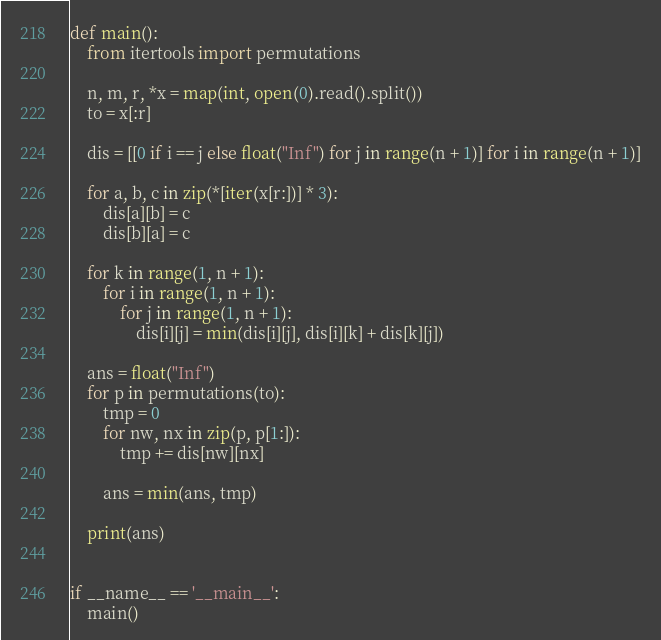<code> <loc_0><loc_0><loc_500><loc_500><_Python_>def main():
    from itertools import permutations

    n, m, r, *x = map(int, open(0).read().split())
    to = x[:r]

    dis = [[0 if i == j else float("Inf") for j in range(n + 1)] for i in range(n + 1)]

    for a, b, c in zip(*[iter(x[r:])] * 3):
        dis[a][b] = c
        dis[b][a] = c

    for k in range(1, n + 1):
        for i in range(1, n + 1):
            for j in range(1, n + 1):
                dis[i][j] = min(dis[i][j], dis[i][k] + dis[k][j])

    ans = float("Inf")
    for p in permutations(to):
        tmp = 0
        for nw, nx in zip(p, p[1:]):
            tmp += dis[nw][nx]
    
        ans = min(ans, tmp)

    print(ans)


if __name__ == '__main__':
    main()
</code> 